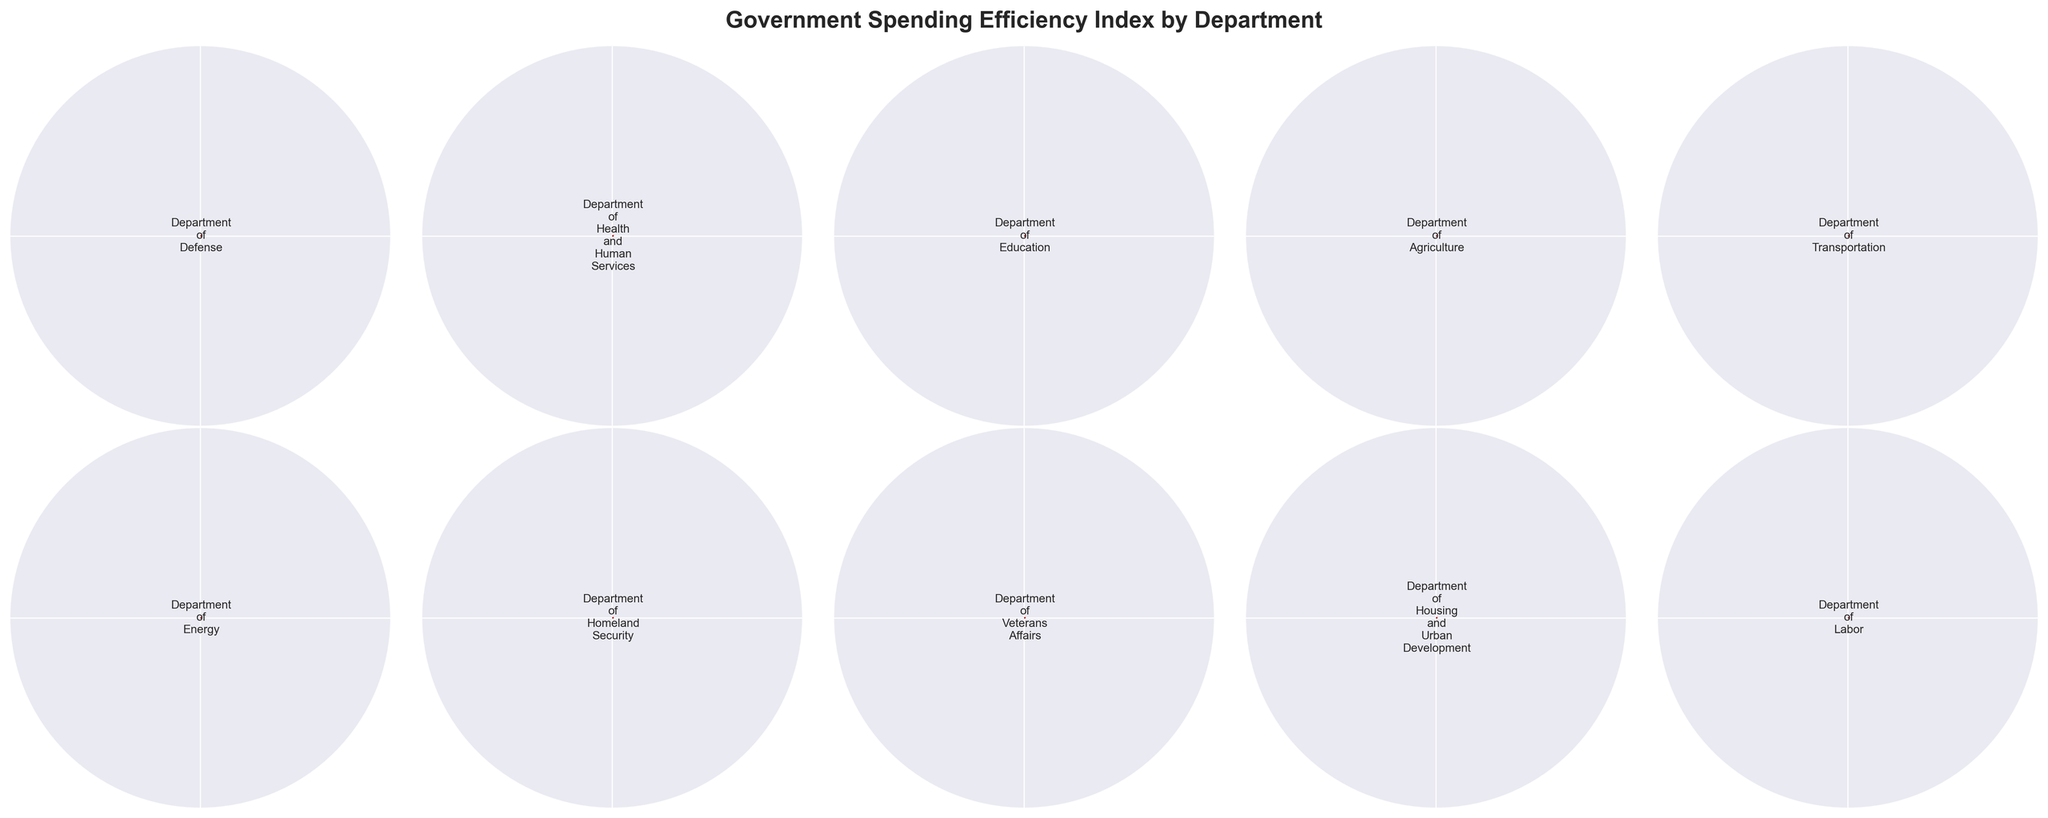What is the title of the figure? The title of the figure is located at the top and provides a brief description of the entire gauge chart plot. According to the given code, the title reads 'Government Spending Efficiency Index by Department'.
Answer: Government Spending Efficiency Index by Department Which department has the highest efficiency score? To find the highest efficiency score, we look at the value inside the colored arc of each department's gauge chart. The Department of Health and Human Services has a score of 78%, which is the highest among all the departments.
Answer: Department of Health and Human Services Which department has the lowest efficiency score? We need to examine the values in the gauge charts to find the lowest score. The Department of Homeland Security has the lowest efficiency score with 62%.
Answer: Department of Homeland Security How many departments have an efficiency score greater than 70%? Counting the number of departments where the efficiency score (inside the colored arc) exceeds 70%, we find Department of Health and Human Services (78%), Department of Education (72%), Department of Energy (75%), Department of Veterans Affairs (73%), and Department of Labor (71%). There are 5 departments in total.
Answer: 5 Compare the efficiency scores of the Department of Defense and the Department of Energy. Which one is higher and by how much? The efficiency score for the Department of Defense is 65%, and for the Department of Energy, it is 75%. The Department of Energy has a higher score by 75% - 65% = 10% points.
Answer: Department of Energy by 10% What is the average efficiency score of all departments? Adding up the efficiency scores of all departments: 65 + 78 + 72 + 70 + 68 + 75 + 62 + 73 + 67 + 71 = 701. Dividing the total by the number of departments (10): 701 / 10 = 70.1
Answer: 70.1 What is the range of efficiency scores depicted in the figure? The range is determined by finding the difference between the highest and lowest efficiency scores. The highest score is 78% (Department of Health and Human Services), and the lowest is 62% (Department of Homeland Security). The range is 78% - 62% = 16%.
Answer: 16% Which two departments have efficiency scores closest to each other? Scanning through the scores, the Department of Transportation (68%) and the Department of Housing and Urban Development (67%) have the closest efficiency scores with a difference of only 1%.
Answer: Department of Transportation and Department of Housing and Urban Development Considering only the departments with efficiency scores above 70%, what is the collective average efficiency score? The departments with scores above 70% are: Department of Health and Human Services (78%), Department of Education (72%), Department of Energy (75%), Department of Veterans Affairs (73%), and Department of Labor (71%). Adding these scores: 78 + 72 + 75 + 73 + 71 = 369. The average is 369 / 5 = 73.8
Answer: 73.8 What proportion of the departments have an efficiency score less than or equal to 70%? The departments with scores ≤ 70% are: Department of Defense (65%), Department of Agriculture (70%), Department of Transportation (68%), Department of Homeland Security (62%), and Department of Housing and Urban Development (67%). There are 5 such departments out of 10. The proportion is 5/10 = 0.5 or 50%.
Answer: 50% 